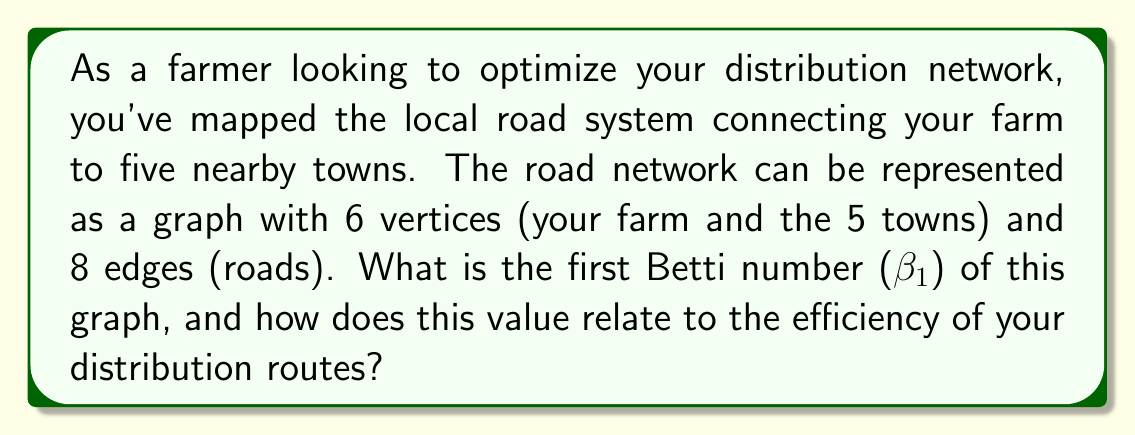Could you help me with this problem? To solve this problem, we'll use concepts from algebraic topology, specifically the calculation of the first Betti number for a graph.

Step 1: Understand the components of the graph
- Vertices (V) = 6 (farm + 5 towns)
- Edges (E) = 8 (roads)
- Connected components (C) = 1 (assuming all towns are reachable)

Step 2: Calculate the first Betti number
The first Betti number (β₁) is calculated using the formula:

$$ \beta_1 = E - V + C $$

Substituting our values:

$$ \beta_1 = 8 - 6 + 1 = 3 $$

Step 3: Interpret the result
The first Betti number represents the number of independent cycles in the graph. In the context of road networks:

- β₁ = 0 would indicate a tree-like structure with no alternative routes
- β₁ > 0 indicates the presence of alternative routes

A higher β₁ generally suggests more route options and potentially greater efficiency in distribution.

Step 4: Relate to distribution efficiency
With β₁ = 3, your road network has three independent cycles. This means:

1. There are multiple ways to reach each town, providing route flexibility.
2. If one road is blocked, you likely have alternative paths.
3. You can optimize routes based on factors like distance, road conditions, or traffic.

However, maintaining more roads (higher E) can be costly. The optimal network balances connectivity with maintenance costs.
Answer: The first Betti number (β₁) of the graph is 3. This indicates a well-connected road network with multiple route options, potentially allowing for efficient distribution by providing alternative paths and flexibility in route planning. 